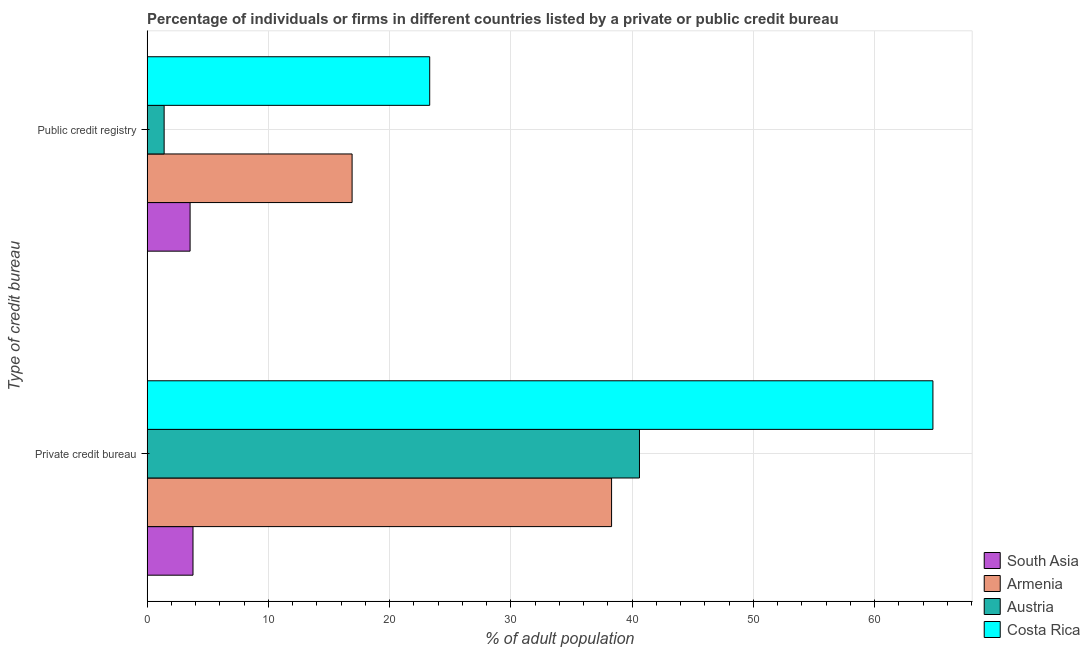How many different coloured bars are there?
Keep it short and to the point. 4. Are the number of bars on each tick of the Y-axis equal?
Make the answer very short. Yes. How many bars are there on the 2nd tick from the top?
Provide a short and direct response. 4. What is the label of the 1st group of bars from the top?
Provide a succinct answer. Public credit registry. What is the percentage of firms listed by public credit bureau in Armenia?
Ensure brevity in your answer.  16.9. Across all countries, what is the maximum percentage of firms listed by public credit bureau?
Offer a very short reply. 23.3. Across all countries, what is the minimum percentage of firms listed by private credit bureau?
Your response must be concise. 3.78. In which country was the percentage of firms listed by private credit bureau maximum?
Provide a short and direct response. Costa Rica. What is the total percentage of firms listed by private credit bureau in the graph?
Provide a succinct answer. 147.48. What is the difference between the percentage of firms listed by public credit bureau in Austria and that in Armenia?
Make the answer very short. -15.5. What is the difference between the percentage of firms listed by private credit bureau in Austria and the percentage of firms listed by public credit bureau in Armenia?
Offer a very short reply. 23.7. What is the average percentage of firms listed by public credit bureau per country?
Offer a very short reply. 11.29. What is the difference between the percentage of firms listed by public credit bureau and percentage of firms listed by private credit bureau in Austria?
Offer a terse response. -39.2. What is the ratio of the percentage of firms listed by private credit bureau in South Asia to that in Austria?
Offer a very short reply. 0.09. In how many countries, is the percentage of firms listed by private credit bureau greater than the average percentage of firms listed by private credit bureau taken over all countries?
Your response must be concise. 3. What does the 4th bar from the bottom in Public credit registry represents?
Ensure brevity in your answer.  Costa Rica. Are the values on the major ticks of X-axis written in scientific E-notation?
Offer a terse response. No. Does the graph contain grids?
Keep it short and to the point. Yes. What is the title of the graph?
Provide a succinct answer. Percentage of individuals or firms in different countries listed by a private or public credit bureau. What is the label or title of the X-axis?
Provide a succinct answer. % of adult population. What is the label or title of the Y-axis?
Keep it short and to the point. Type of credit bureau. What is the % of adult population of South Asia in Private credit bureau?
Provide a short and direct response. 3.78. What is the % of adult population in Armenia in Private credit bureau?
Keep it short and to the point. 38.3. What is the % of adult population of Austria in Private credit bureau?
Your response must be concise. 40.6. What is the % of adult population of Costa Rica in Private credit bureau?
Provide a succinct answer. 64.8. What is the % of adult population of South Asia in Public credit registry?
Your answer should be compact. 3.54. What is the % of adult population of Austria in Public credit registry?
Your answer should be very brief. 1.4. What is the % of adult population of Costa Rica in Public credit registry?
Offer a very short reply. 23.3. Across all Type of credit bureau, what is the maximum % of adult population of South Asia?
Provide a short and direct response. 3.78. Across all Type of credit bureau, what is the maximum % of adult population of Armenia?
Keep it short and to the point. 38.3. Across all Type of credit bureau, what is the maximum % of adult population of Austria?
Ensure brevity in your answer.  40.6. Across all Type of credit bureau, what is the maximum % of adult population of Costa Rica?
Offer a very short reply. 64.8. Across all Type of credit bureau, what is the minimum % of adult population of South Asia?
Provide a succinct answer. 3.54. Across all Type of credit bureau, what is the minimum % of adult population of Austria?
Offer a very short reply. 1.4. Across all Type of credit bureau, what is the minimum % of adult population of Costa Rica?
Offer a very short reply. 23.3. What is the total % of adult population of South Asia in the graph?
Give a very brief answer. 7.32. What is the total % of adult population in Armenia in the graph?
Your answer should be compact. 55.2. What is the total % of adult population of Austria in the graph?
Offer a terse response. 42. What is the total % of adult population of Costa Rica in the graph?
Offer a very short reply. 88.1. What is the difference between the % of adult population in South Asia in Private credit bureau and that in Public credit registry?
Your answer should be very brief. 0.24. What is the difference between the % of adult population in Armenia in Private credit bureau and that in Public credit registry?
Make the answer very short. 21.4. What is the difference between the % of adult population of Austria in Private credit bureau and that in Public credit registry?
Give a very brief answer. 39.2. What is the difference between the % of adult population in Costa Rica in Private credit bureau and that in Public credit registry?
Give a very brief answer. 41.5. What is the difference between the % of adult population of South Asia in Private credit bureau and the % of adult population of Armenia in Public credit registry?
Keep it short and to the point. -13.12. What is the difference between the % of adult population of South Asia in Private credit bureau and the % of adult population of Austria in Public credit registry?
Provide a short and direct response. 2.38. What is the difference between the % of adult population of South Asia in Private credit bureau and the % of adult population of Costa Rica in Public credit registry?
Offer a terse response. -19.52. What is the difference between the % of adult population in Armenia in Private credit bureau and the % of adult population in Austria in Public credit registry?
Provide a short and direct response. 36.9. What is the difference between the % of adult population in Armenia in Private credit bureau and the % of adult population in Costa Rica in Public credit registry?
Provide a short and direct response. 15. What is the difference between the % of adult population in Austria in Private credit bureau and the % of adult population in Costa Rica in Public credit registry?
Your response must be concise. 17.3. What is the average % of adult population of South Asia per Type of credit bureau?
Make the answer very short. 3.66. What is the average % of adult population of Armenia per Type of credit bureau?
Your response must be concise. 27.6. What is the average % of adult population of Austria per Type of credit bureau?
Offer a terse response. 21. What is the average % of adult population in Costa Rica per Type of credit bureau?
Your answer should be compact. 44.05. What is the difference between the % of adult population in South Asia and % of adult population in Armenia in Private credit bureau?
Ensure brevity in your answer.  -34.52. What is the difference between the % of adult population of South Asia and % of adult population of Austria in Private credit bureau?
Give a very brief answer. -36.82. What is the difference between the % of adult population of South Asia and % of adult population of Costa Rica in Private credit bureau?
Keep it short and to the point. -61.02. What is the difference between the % of adult population of Armenia and % of adult population of Costa Rica in Private credit bureau?
Provide a short and direct response. -26.5. What is the difference between the % of adult population in Austria and % of adult population in Costa Rica in Private credit bureau?
Make the answer very short. -24.2. What is the difference between the % of adult population in South Asia and % of adult population in Armenia in Public credit registry?
Provide a short and direct response. -13.36. What is the difference between the % of adult population of South Asia and % of adult population of Austria in Public credit registry?
Ensure brevity in your answer.  2.14. What is the difference between the % of adult population of South Asia and % of adult population of Costa Rica in Public credit registry?
Offer a very short reply. -19.76. What is the difference between the % of adult population of Armenia and % of adult population of Austria in Public credit registry?
Give a very brief answer. 15.5. What is the difference between the % of adult population of Austria and % of adult population of Costa Rica in Public credit registry?
Your response must be concise. -21.9. What is the ratio of the % of adult population in South Asia in Private credit bureau to that in Public credit registry?
Offer a terse response. 1.07. What is the ratio of the % of adult population in Armenia in Private credit bureau to that in Public credit registry?
Keep it short and to the point. 2.27. What is the ratio of the % of adult population in Costa Rica in Private credit bureau to that in Public credit registry?
Ensure brevity in your answer.  2.78. What is the difference between the highest and the second highest % of adult population of South Asia?
Keep it short and to the point. 0.24. What is the difference between the highest and the second highest % of adult population in Armenia?
Ensure brevity in your answer.  21.4. What is the difference between the highest and the second highest % of adult population of Austria?
Your answer should be very brief. 39.2. What is the difference between the highest and the second highest % of adult population in Costa Rica?
Your answer should be very brief. 41.5. What is the difference between the highest and the lowest % of adult population in South Asia?
Ensure brevity in your answer.  0.24. What is the difference between the highest and the lowest % of adult population in Armenia?
Make the answer very short. 21.4. What is the difference between the highest and the lowest % of adult population in Austria?
Your answer should be very brief. 39.2. What is the difference between the highest and the lowest % of adult population of Costa Rica?
Offer a terse response. 41.5. 